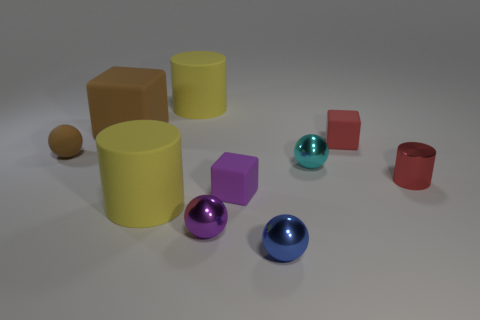How many tiny objects are matte blocks or red things? There are a total of five objects that meet the criteria. This includes one large matte red cylinder, one tiny red cylinder, and three small matte blocks (one purple cube, and two identical yellow cylinders). 